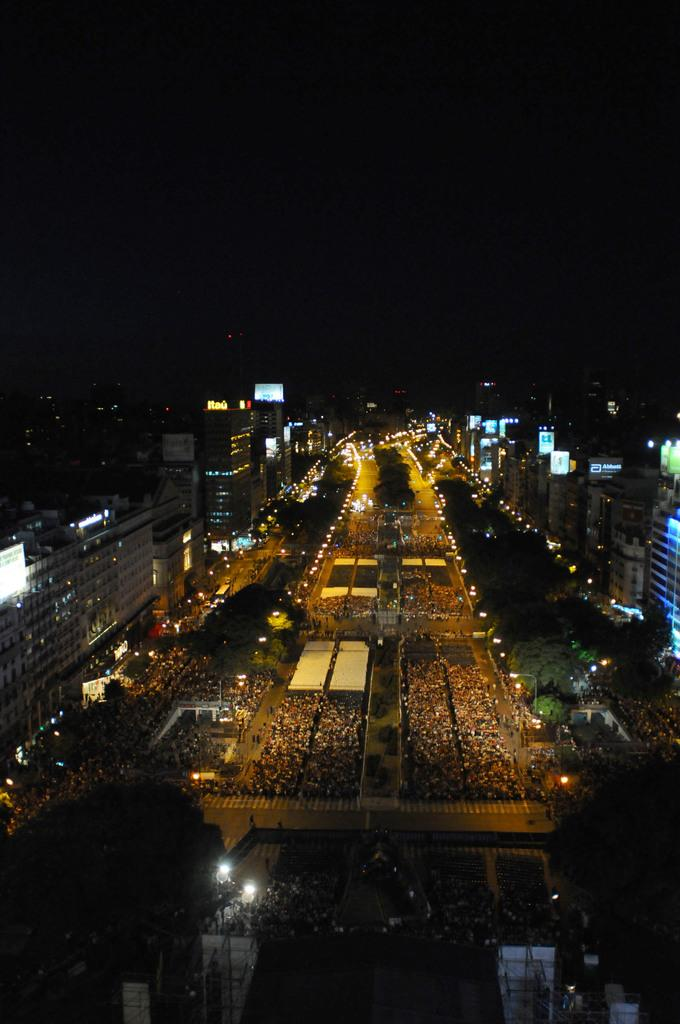What type of structures are present in the image? There are buildings in the image. What can be seen illuminating the scene in the image? There are lights visible in the image. How would you describe the overall lighting condition in the image? The background of the image appears to be dark. What time of day is it in the image, and what season is it? The time of day and season cannot be determined from the image, as there are no specific indicators present. Can you see any roses blooming in the image? There are no roses visible in the image. 